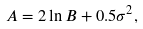<formula> <loc_0><loc_0><loc_500><loc_500>A = 2 \ln B + 0 . 5 \sigma ^ { 2 } ,</formula> 